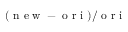Convert formula to latex. <formula><loc_0><loc_0><loc_500><loc_500>( n e w - o r i ) / o r i</formula> 